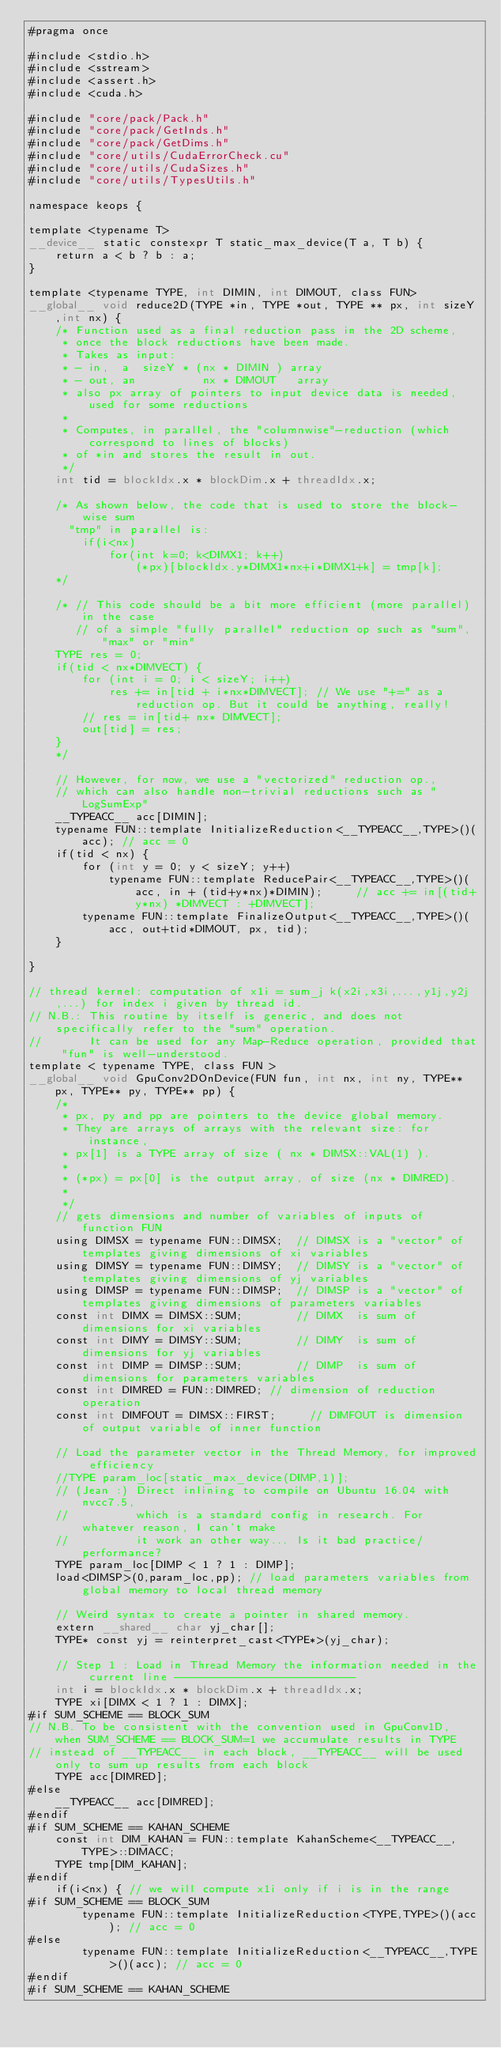Convert code to text. <code><loc_0><loc_0><loc_500><loc_500><_Cuda_>#pragma once

#include <stdio.h>
#include <sstream>
#include <assert.h>
#include <cuda.h>

#include "core/pack/Pack.h"
#include "core/pack/GetInds.h"
#include "core/pack/GetDims.h"
#include "core/utils/CudaErrorCheck.cu"
#include "core/utils/CudaSizes.h"
#include "core/utils/TypesUtils.h"

namespace keops {

template <typename T>
__device__ static constexpr T static_max_device(T a, T b) {
    return a < b ? b : a;
}

template <typename TYPE, int DIMIN, int DIMOUT, class FUN>
__global__ void reduce2D(TYPE *in, TYPE *out, TYPE ** px, int sizeY,int nx) {
    /* Function used as a final reduction pass in the 2D scheme,
     * once the block reductions have been made.
     * Takes as input:
     * - in,  a  sizeY * (nx * DIMIN ) array
     * - out, an          nx * DIMOUT   array
     * also px array of pointers to input device data is needed, used for some reductions
     *
     * Computes, in parallel, the "columnwise"-reduction (which correspond to lines of blocks)
     * of *in and stores the result in out.
     */
    int tid = blockIdx.x * blockDim.x + threadIdx.x;

    /* As shown below, the code that is used to store the block-wise sum
      "tmp" in parallel is:
        if(i<nx)
            for(int k=0; k<DIMX1; k++)
                (*px)[blockIdx.y*DIMX1*nx+i*DIMX1+k] = tmp[k];
    */

    /* // This code should be a bit more efficient (more parallel) in the case
       // of a simple "fully parallel" reduction op such as "sum", "max" or "min"
    TYPE res = 0;
    if(tid < nx*DIMVECT) {
        for (int i = 0; i < sizeY; i++)
            res += in[tid + i*nx*DIMVECT]; // We use "+=" as a reduction op. But it could be anything, really!
        // res = in[tid+ nx* DIMVECT];
        out[tid] = res;
    }
    */

    // However, for now, we use a "vectorized" reduction op.,
    // which can also handle non-trivial reductions such as "LogSumExp"
    __TYPEACC__ acc[DIMIN];
    typename FUN::template InitializeReduction<__TYPEACC__,TYPE>()(acc); // acc = 0
    if(tid < nx) {
        for (int y = 0; y < sizeY; y++)
            typename FUN::template ReducePair<__TYPEACC__,TYPE>()(acc, in + (tid+y*nx)*DIMIN);     // acc += in[(tid+y*nx) *DIMVECT : +DIMVECT];
        typename FUN::template FinalizeOutput<__TYPEACC__,TYPE>()(acc, out+tid*DIMOUT, px, tid);
    }

}

// thread kernel: computation of x1i = sum_j k(x2i,x3i,...,y1j,y2j,...) for index i given by thread id.
// N.B.: This routine by itself is generic, and does not specifically refer to the "sum" operation.
//       It can be used for any Map-Reduce operation, provided that "fun" is well-understood.
template < typename TYPE, class FUN >
__global__ void GpuConv2DOnDevice(FUN fun, int nx, int ny, TYPE** px, TYPE** py, TYPE** pp) {
    /*
     * px, py and pp are pointers to the device global memory.
     * They are arrays of arrays with the relevant size: for instance,
     * px[1] is a TYPE array of size ( nx * DIMSX::VAL(1) ).
     *
     * (*px) = px[0] is the output array, of size (nx * DIMRED).
     *
     */
    // gets dimensions and number of variables of inputs of function FUN
    using DIMSX = typename FUN::DIMSX;  // DIMSX is a "vector" of templates giving dimensions of xi variables
    using DIMSY = typename FUN::DIMSY;  // DIMSY is a "vector" of templates giving dimensions of yj variables
    using DIMSP = typename FUN::DIMSP;  // DIMSP is a "vector" of templates giving dimensions of parameters variables
    const int DIMX = DIMSX::SUM;        // DIMX  is sum of dimensions for xi variables
    const int DIMY = DIMSY::SUM;        // DIMY  is sum of dimensions for yj variables
    const int DIMP = DIMSP::SUM;        // DIMP  is sum of dimensions for parameters variables
    const int DIMRED = FUN::DIMRED; // dimension of reduction operation
    const int DIMFOUT = DIMSX::FIRST;     // DIMFOUT is dimension of output variable of inner function

    // Load the parameter vector in the Thread Memory, for improved efficiency
    //TYPE param_loc[static_max_device(DIMP,1)];
    // (Jean :) Direct inlining to compile on Ubuntu 16.04 with nvcc7.5,
    //          which is a standard config in research. For whatever reason, I can't make
    //          it work an other way... Is it bad practice/performance?
    TYPE param_loc[DIMP < 1 ? 1 : DIMP];
	load<DIMSP>(0,param_loc,pp); // load parameters variables from global memory to local thread memory
    
    // Weird syntax to create a pointer in shared memory.
    extern __shared__ char yj_char[];
    TYPE* const yj = reinterpret_cast<TYPE*>(yj_char);

    // Step 1 : Load in Thread Memory the information needed in the current line ---------------------------
    int i = blockIdx.x * blockDim.x + threadIdx.x;
    TYPE xi[DIMX < 1 ? 1 : DIMX];
#if SUM_SCHEME == BLOCK_SUM 
// N.B. To be consistent with the convention used in GpuConv1D, when SUM_SCHEME == BLOCK_SUM=1 we accumulate results in TYPE 
// instead of __TYPEACC__ in each block, __TYPEACC__ will be used only to sum up results from each block
    TYPE acc[DIMRED];
#else
    __TYPEACC__ acc[DIMRED];
#endif
#if SUM_SCHEME == KAHAN_SCHEME
    const int DIM_KAHAN = FUN::template KahanScheme<__TYPEACC__,TYPE>::DIMACC;
    TYPE tmp[DIM_KAHAN];
#endif
    if(i<nx) { // we will compute x1i only if i is in the range
#if SUM_SCHEME == BLOCK_SUM         
        typename FUN::template InitializeReduction<TYPE,TYPE>()(acc); // acc = 0
#else
        typename FUN::template InitializeReduction<__TYPEACC__,TYPE>()(acc); // acc = 0
#endif
#if SUM_SCHEME == KAHAN_SCHEME</code> 